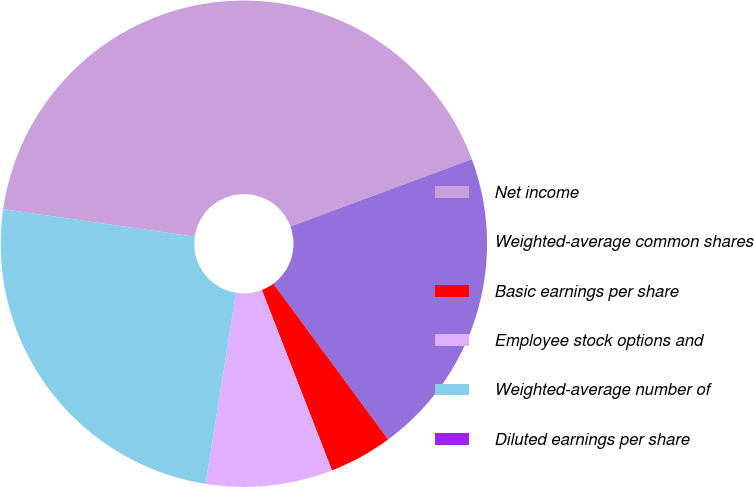<chart> <loc_0><loc_0><loc_500><loc_500><pie_chart><fcel>Net income<fcel>Weighted-average common shares<fcel>Basic earnings per share<fcel>Employee stock options and<fcel>Weighted-average number of<fcel>Diluted earnings per share<nl><fcel>42.08%<fcel>20.54%<fcel>4.21%<fcel>8.42%<fcel>24.75%<fcel>0.0%<nl></chart> 